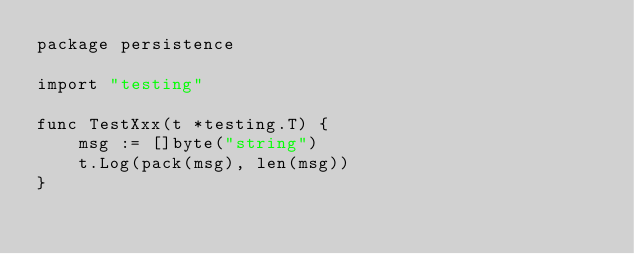Convert code to text. <code><loc_0><loc_0><loc_500><loc_500><_Go_>package persistence

import "testing"

func TestXxx(t *testing.T) {
	msg := []byte("string")
	t.Log(pack(msg), len(msg))
}
</code> 